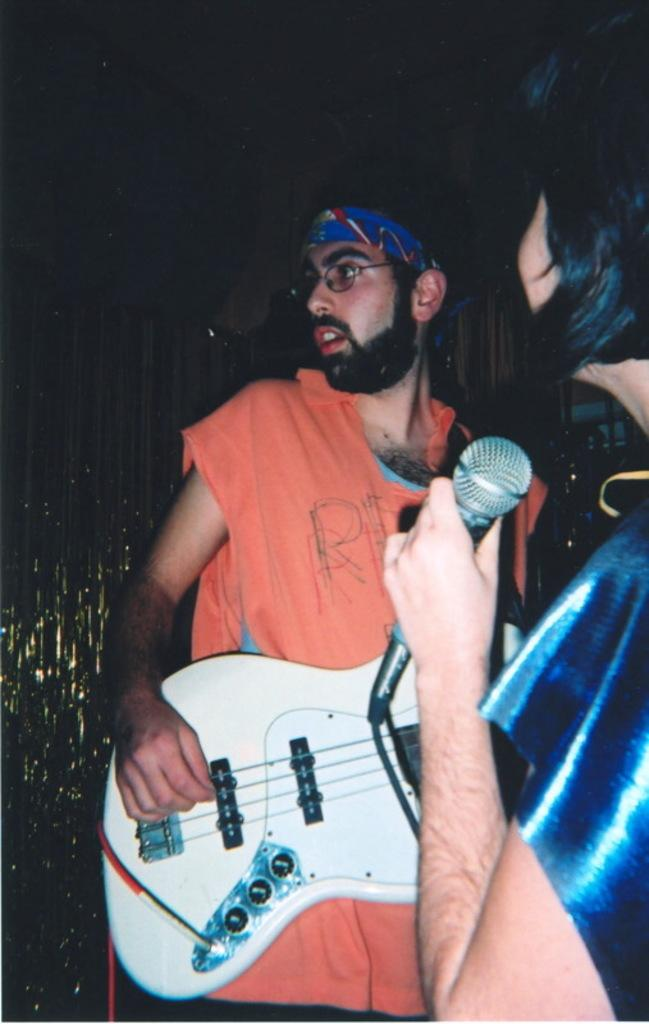What is the man in the image doing? The man is playing a guitar in the image. What is the man wearing? The man is wearing an orange t-shirt in the image. Can you describe any additional accessories the man is wearing? Yes, there is a blue color band around the man's head. What is the person holding in their hand? The person is holding a microphone in their hand. What type of sweater is the man wearing in the image? The man is not wearing a sweater in the image; he is wearing an orange t-shirt. What is the man's crush doing in the image? There is no mention of a crush in the image, and therefore no such activity can be observed. 